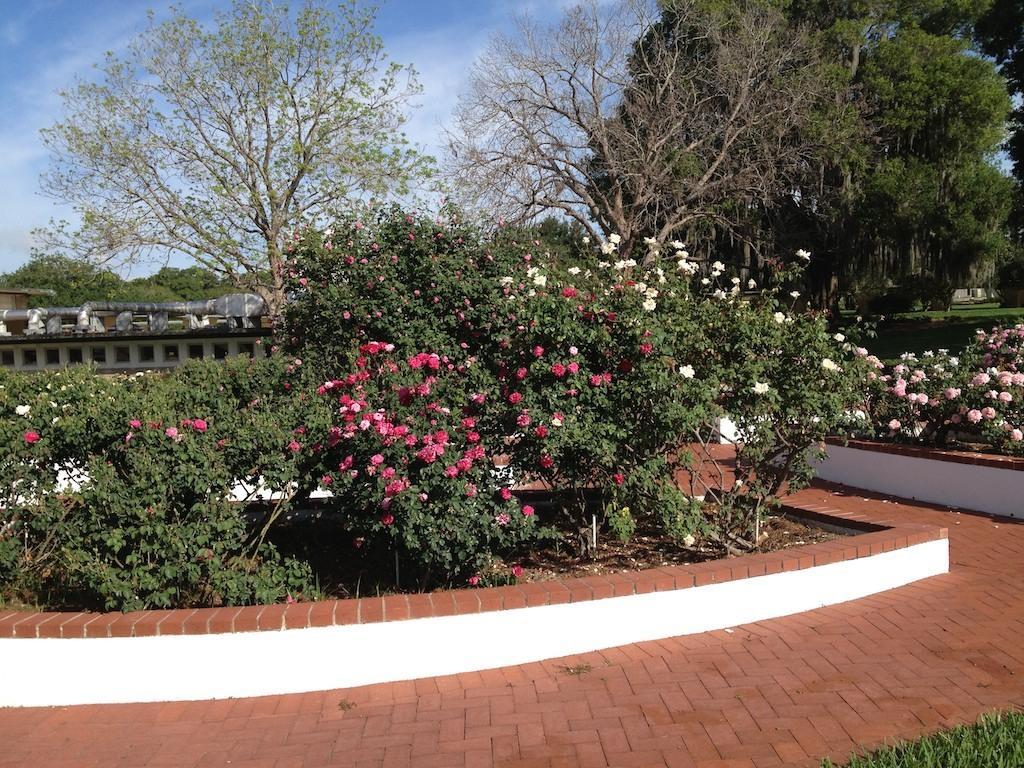Can you describe this image briefly? In this image there are plants, trees, flowers, path and there are pipes on top of the building. In the background there is the sky. 